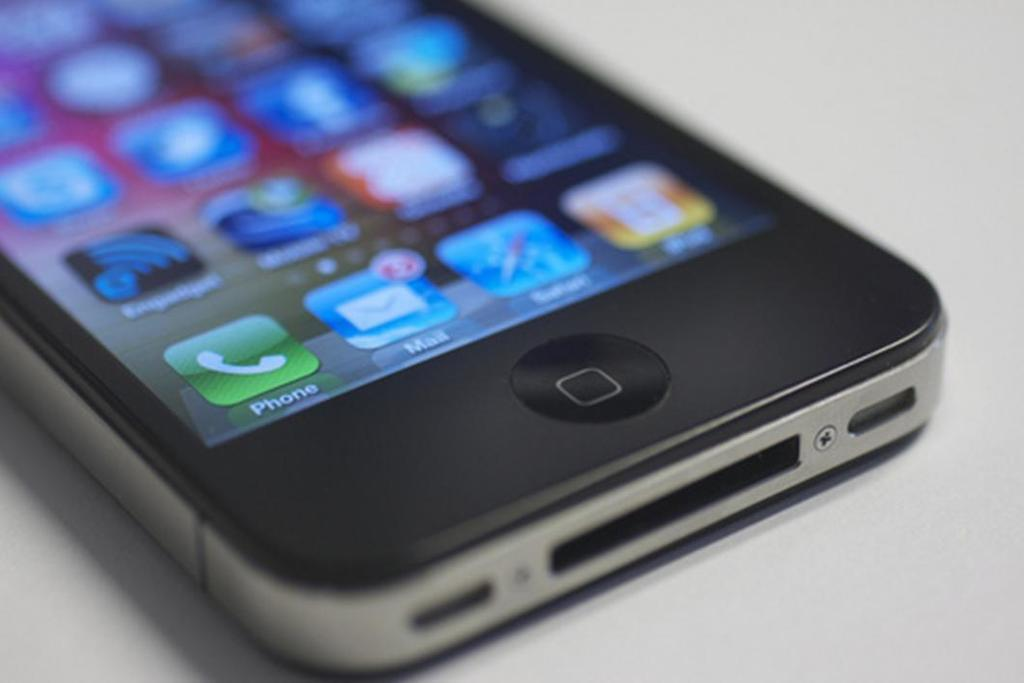What is the main subject of the image? The main subject of the image is a mobile. What can be seen on the mobile's display? There are icons visible on the display of the mobile. What type of flesh can be seen on the mobile's display? There is no flesh visible on the mobile's display; the image only shows icons. 